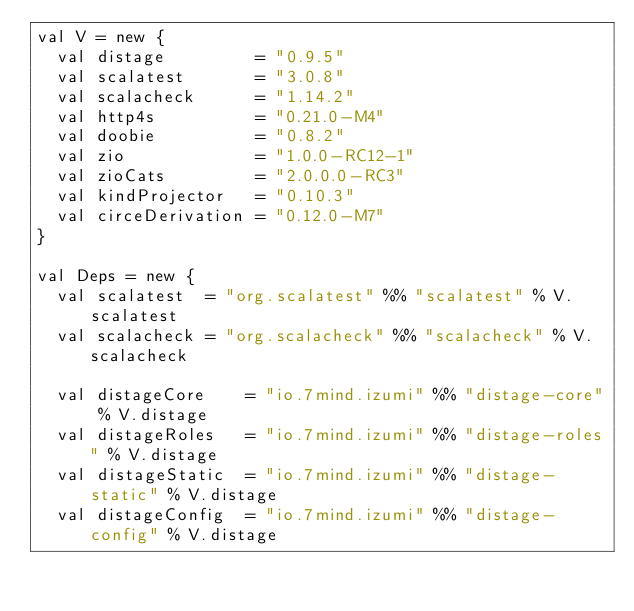<code> <loc_0><loc_0><loc_500><loc_500><_Scala_>val V = new {
  val distage         = "0.9.5"
  val scalatest       = "3.0.8"
  val scalacheck      = "1.14.2"
  val http4s          = "0.21.0-M4"
  val doobie          = "0.8.2"
  val zio             = "1.0.0-RC12-1"
  val zioCats         = "2.0.0.0-RC3"
  val kindProjector   = "0.10.3"
  val circeDerivation = "0.12.0-M7"
}

val Deps = new {
  val scalatest  = "org.scalatest" %% "scalatest" % V.scalatest
  val scalacheck = "org.scalacheck" %% "scalacheck" % V.scalacheck

  val distageCore    = "io.7mind.izumi" %% "distage-core" % V.distage
  val distageRoles   = "io.7mind.izumi" %% "distage-roles" % V.distage
  val distageStatic  = "io.7mind.izumi" %% "distage-static" % V.distage
  val distageConfig  = "io.7mind.izumi" %% "distage-config" % V.distage</code> 